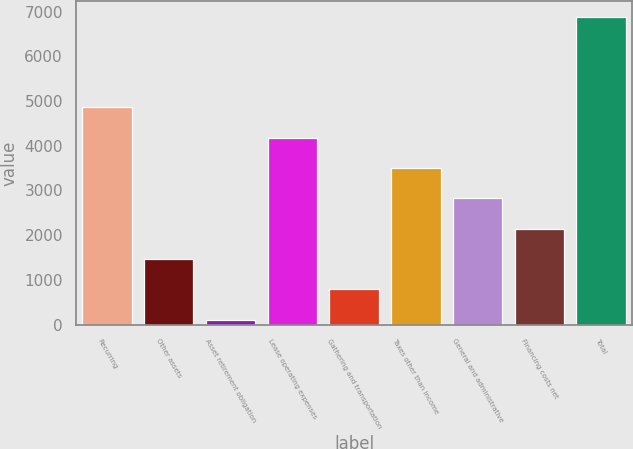Convert chart to OTSL. <chart><loc_0><loc_0><loc_500><loc_500><bar_chart><fcel>Recurring<fcel>Other assets<fcel>Asset retirement obligation<fcel>Lease operating expenses<fcel>Gathering and transportation<fcel>Taxes other than income<fcel>General and administrative<fcel>Financing costs net<fcel>Total<nl><fcel>4853.5<fcel>1466<fcel>111<fcel>4176<fcel>788.5<fcel>3498.5<fcel>2821<fcel>2143.5<fcel>6886<nl></chart> 